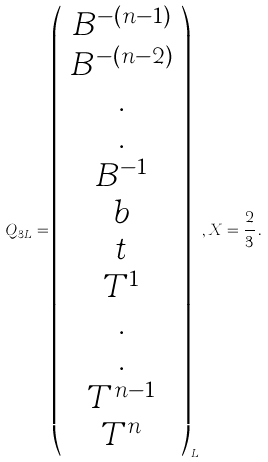<formula> <loc_0><loc_0><loc_500><loc_500>Q _ { 3 L } = \left ( \begin{array} { c } B ^ { - ( n - 1 ) } \\ B ^ { - ( n - 2 ) } \\ . \\ . \\ B ^ { - 1 } \\ b \\ t \\ T ^ { 1 } \\ . \\ . \\ T ^ { n - 1 } \\ T ^ { n } \end{array} \right ) _ { L } , X = \frac { 2 } { 3 } \, .</formula> 